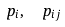Convert formula to latex. <formula><loc_0><loc_0><loc_500><loc_500>p _ { i } , \ \ p _ { i j }</formula> 